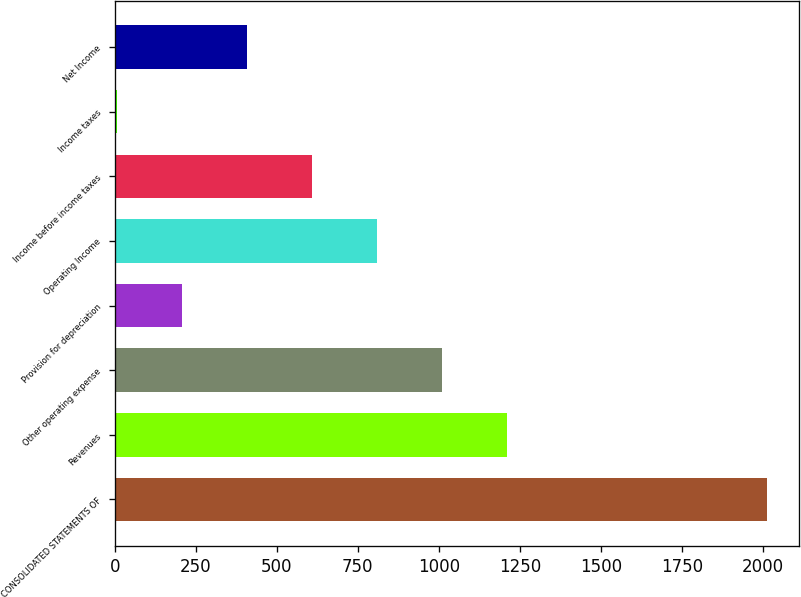<chart> <loc_0><loc_0><loc_500><loc_500><bar_chart><fcel>CONSOLIDATED STATEMENTS OF<fcel>Revenues<fcel>Other operating expense<fcel>Provision for depreciation<fcel>Operating Income<fcel>Income before income taxes<fcel>Income taxes<fcel>Net Income<nl><fcel>2011<fcel>1208.96<fcel>1008.45<fcel>206.41<fcel>807.94<fcel>607.43<fcel>5.9<fcel>406.92<nl></chart> 